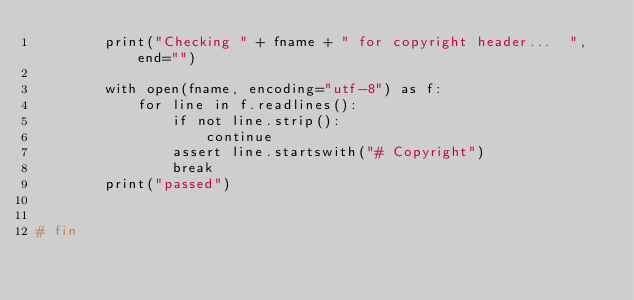<code> <loc_0><loc_0><loc_500><loc_500><_Python_>        print("Checking " + fname + " for copyright header...  ", end="")

        with open(fname, encoding="utf-8") as f:
            for line in f.readlines():
                if not line.strip():
                    continue
                assert line.startswith("# Copyright")
                break
        print("passed")


# fin
</code> 